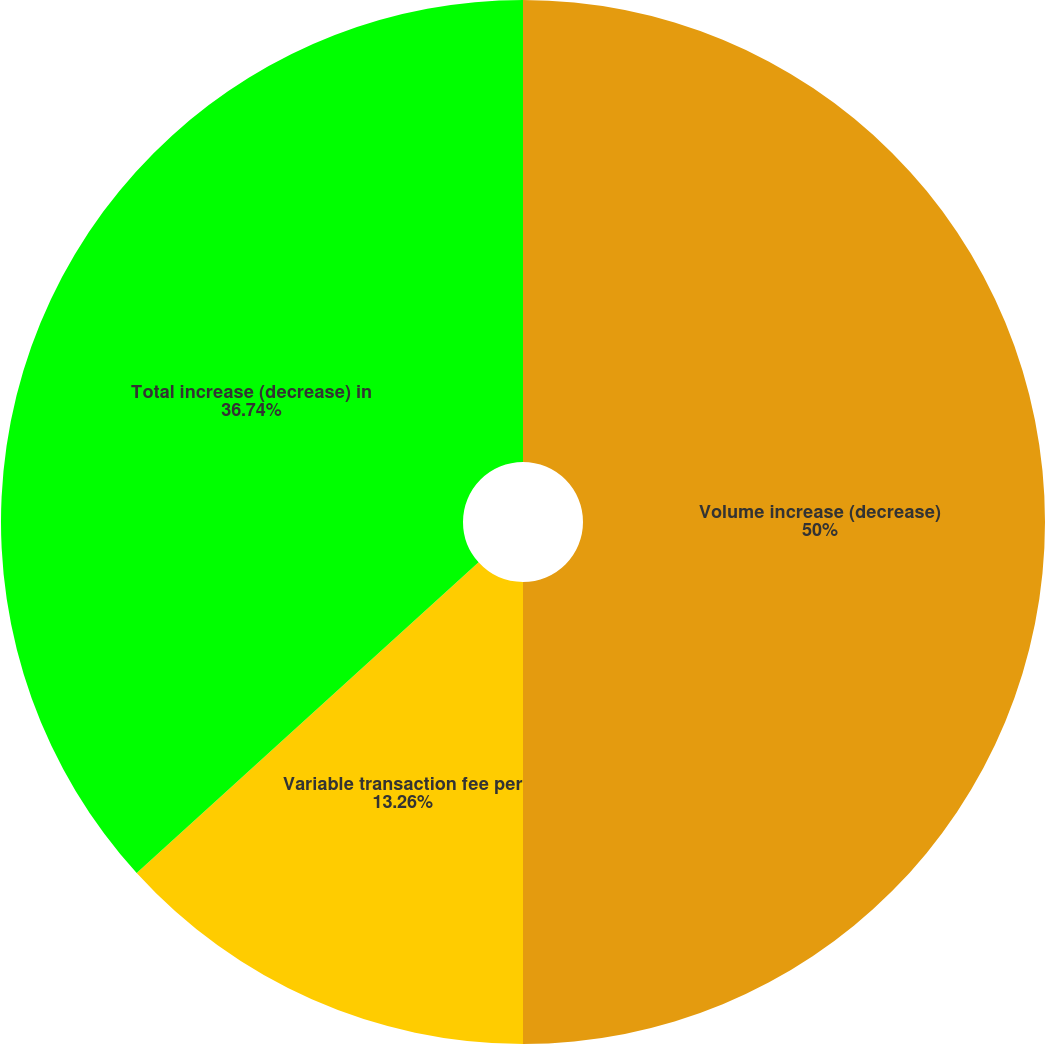Convert chart. <chart><loc_0><loc_0><loc_500><loc_500><pie_chart><fcel>Volume increase (decrease)<fcel>Variable transaction fee per<fcel>Total increase (decrease) in<nl><fcel>50.0%<fcel>13.26%<fcel>36.74%<nl></chart> 